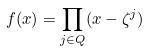<formula> <loc_0><loc_0><loc_500><loc_500>f ( x ) = \prod _ { j \in Q } ( x - \zeta ^ { j } )</formula> 